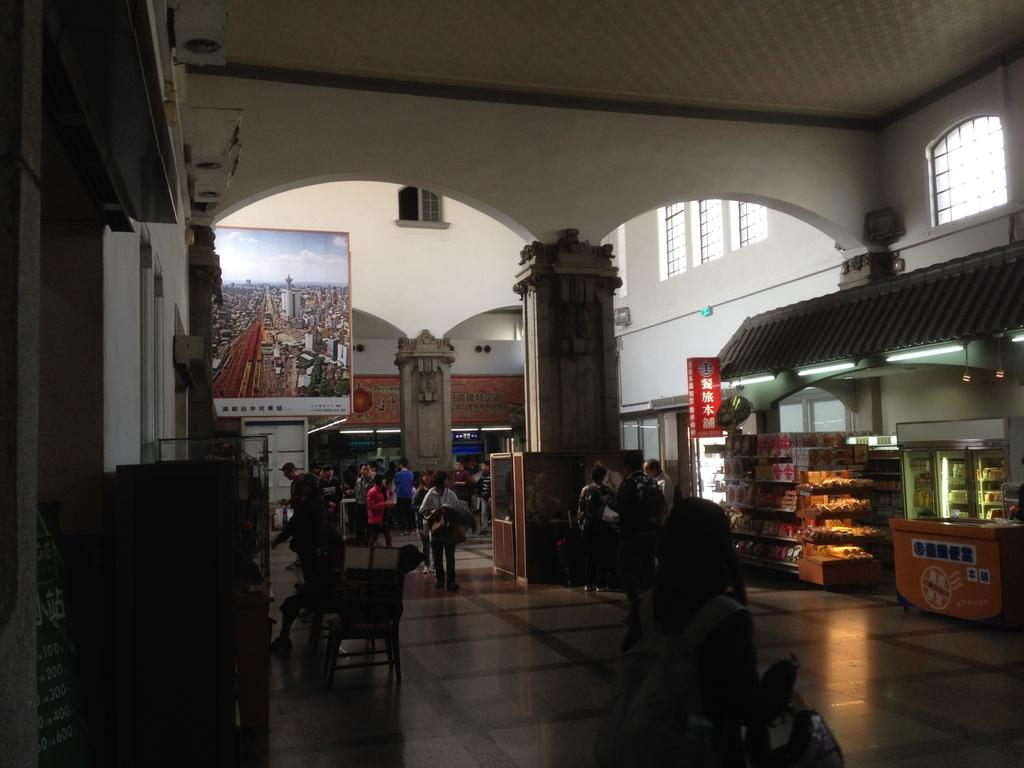What type of location is depicted in the image? The image shows an inner view of a building. What can be found within this building? There are stores visible in the image. Are there any decorative elements in the image? Yes, there is a photo frame on the wall in the image. Can you describe the people in the image? There are people standing in the image. What type of leg injury can be seen on the person in the image? There is no indication of a leg injury or any injuries in the image. Is there a fire visible in the image? No, there is no fire present in the image. 